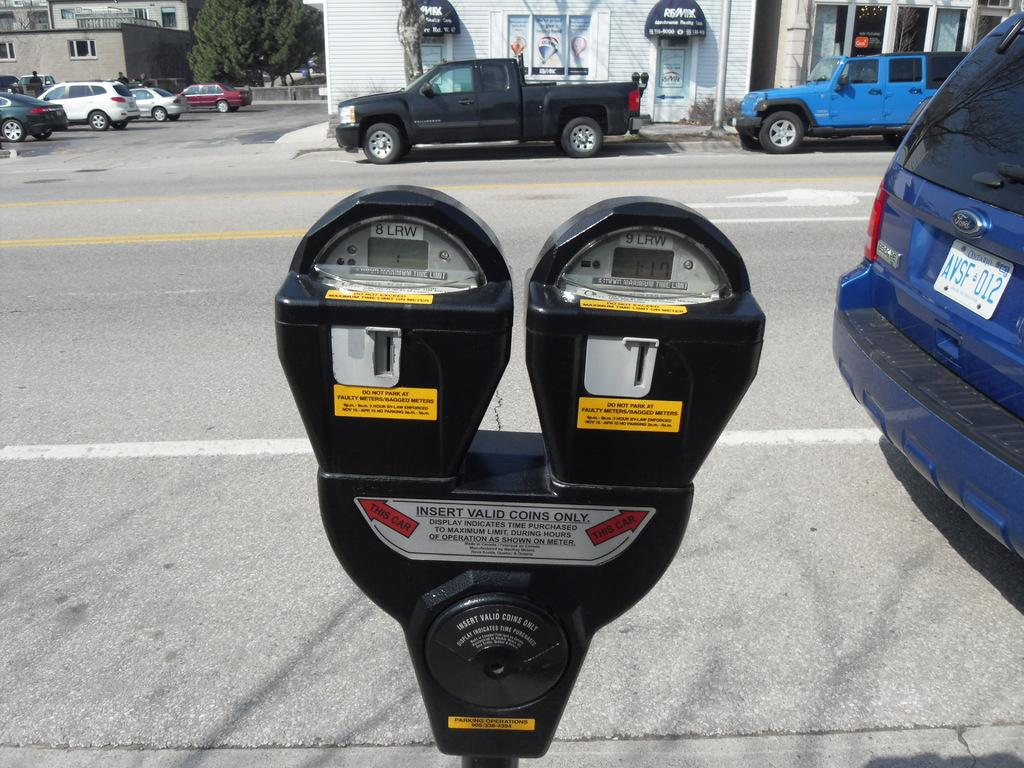<image>
Render a clear and concise summary of the photo. A double parking meter with a sign to insert valid coins only. 